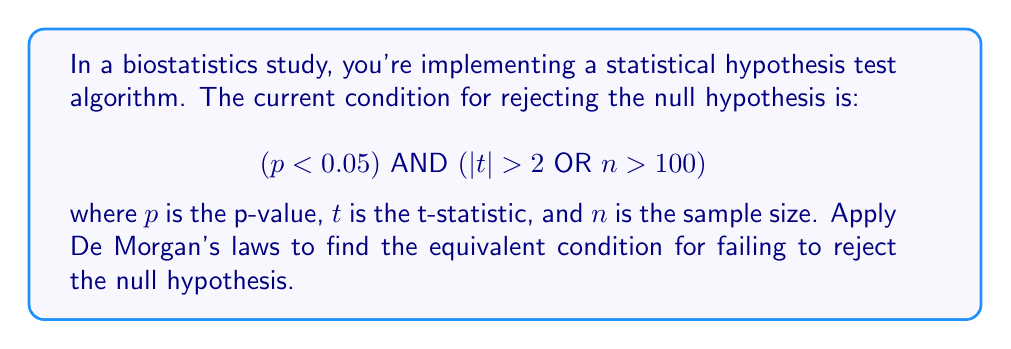Can you solve this math problem? To solve this problem, we'll apply De Morgan's laws to negate the given condition. The steps are as follows:

1) First, recall De Morgan's laws:
   - NOT (A AND B) = (NOT A) OR (NOT B)
   - NOT (A OR B) = (NOT A) AND (NOT B)

2) The condition for rejecting the null hypothesis is:
   $$(p < 0.05) \text{ AND } (|t| > 2 \text{ OR } n > 100)$$

3) To find the condition for failing to reject, we need to negate this entire expression:
   $$\text{NOT}[(p < 0.05) \text{ AND } (|t| > 2 \text{ OR } n > 100)]$$

4) Applying the first De Morgan's law:
   $$\text{NOT}(p < 0.05) \text{ OR NOT}(|t| > 2 \text{ OR } n > 100)$$

5) Simplify NOT$(p < 0.05)$:
   $$(p \geq 0.05) \text{ OR NOT}(|t| > 2 \text{ OR } n > 100)$$

6) Apply the second De Morgan's law to the right part:
   $$(p \geq 0.05) \text{ OR } (|t| \leq 2 \text{ AND } n \leq 100)$$

This is the equivalent condition for failing to reject the null hypothesis.
Answer: $$(p \geq 0.05) \text{ OR } (|t| \leq 2 \text{ AND } n \leq 100)$$ 